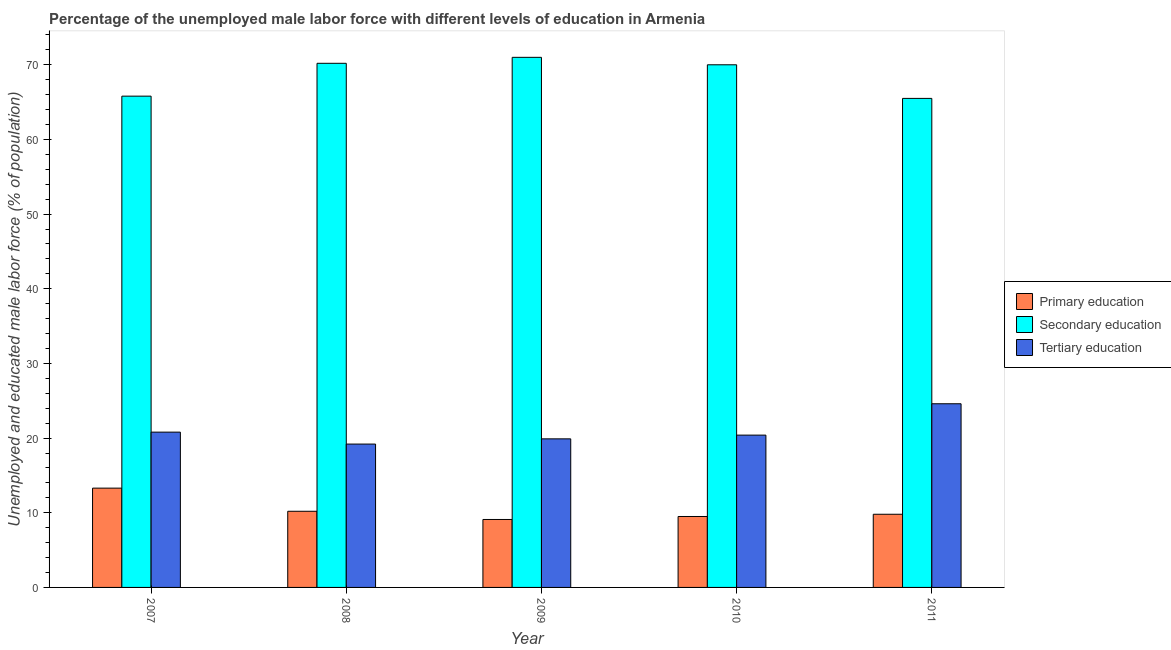Are the number of bars on each tick of the X-axis equal?
Give a very brief answer. Yes. How many bars are there on the 4th tick from the left?
Offer a terse response. 3. What is the label of the 1st group of bars from the left?
Offer a terse response. 2007. What is the percentage of male labor force who received primary education in 2008?
Your answer should be very brief. 10.2. Across all years, what is the maximum percentage of male labor force who received tertiary education?
Your answer should be compact. 24.6. Across all years, what is the minimum percentage of male labor force who received primary education?
Ensure brevity in your answer.  9.1. In which year was the percentage of male labor force who received tertiary education maximum?
Make the answer very short. 2011. What is the total percentage of male labor force who received tertiary education in the graph?
Give a very brief answer. 104.9. What is the difference between the percentage of male labor force who received tertiary education in 2007 and the percentage of male labor force who received secondary education in 2008?
Ensure brevity in your answer.  1.6. What is the average percentage of male labor force who received primary education per year?
Make the answer very short. 10.38. What is the ratio of the percentage of male labor force who received tertiary education in 2009 to that in 2010?
Offer a very short reply. 0.98. Is the difference between the percentage of male labor force who received tertiary education in 2010 and 2011 greater than the difference between the percentage of male labor force who received primary education in 2010 and 2011?
Offer a terse response. No. What is the difference between the highest and the second highest percentage of male labor force who received secondary education?
Ensure brevity in your answer.  0.8. What is the difference between the highest and the lowest percentage of male labor force who received primary education?
Your answer should be compact. 4.2. In how many years, is the percentage of male labor force who received primary education greater than the average percentage of male labor force who received primary education taken over all years?
Provide a succinct answer. 1. Is the sum of the percentage of male labor force who received secondary education in 2010 and 2011 greater than the maximum percentage of male labor force who received tertiary education across all years?
Provide a succinct answer. Yes. What does the 2nd bar from the left in 2011 represents?
Provide a succinct answer. Secondary education. How many bars are there?
Ensure brevity in your answer.  15. Are all the bars in the graph horizontal?
Your response must be concise. No. How many years are there in the graph?
Give a very brief answer. 5. What is the difference between two consecutive major ticks on the Y-axis?
Ensure brevity in your answer.  10. How many legend labels are there?
Ensure brevity in your answer.  3. What is the title of the graph?
Offer a very short reply. Percentage of the unemployed male labor force with different levels of education in Armenia. What is the label or title of the Y-axis?
Provide a succinct answer. Unemployed and educated male labor force (% of population). What is the Unemployed and educated male labor force (% of population) in Primary education in 2007?
Your answer should be compact. 13.3. What is the Unemployed and educated male labor force (% of population) in Secondary education in 2007?
Your answer should be compact. 65.8. What is the Unemployed and educated male labor force (% of population) of Tertiary education in 2007?
Your answer should be compact. 20.8. What is the Unemployed and educated male labor force (% of population) in Primary education in 2008?
Ensure brevity in your answer.  10.2. What is the Unemployed and educated male labor force (% of population) in Secondary education in 2008?
Give a very brief answer. 70.2. What is the Unemployed and educated male labor force (% of population) in Tertiary education in 2008?
Your answer should be very brief. 19.2. What is the Unemployed and educated male labor force (% of population) of Primary education in 2009?
Give a very brief answer. 9.1. What is the Unemployed and educated male labor force (% of population) of Tertiary education in 2009?
Offer a terse response. 19.9. What is the Unemployed and educated male labor force (% of population) of Primary education in 2010?
Offer a terse response. 9.5. What is the Unemployed and educated male labor force (% of population) of Secondary education in 2010?
Give a very brief answer. 70. What is the Unemployed and educated male labor force (% of population) of Tertiary education in 2010?
Offer a very short reply. 20.4. What is the Unemployed and educated male labor force (% of population) of Primary education in 2011?
Keep it short and to the point. 9.8. What is the Unemployed and educated male labor force (% of population) of Secondary education in 2011?
Offer a very short reply. 65.5. What is the Unemployed and educated male labor force (% of population) of Tertiary education in 2011?
Provide a short and direct response. 24.6. Across all years, what is the maximum Unemployed and educated male labor force (% of population) of Primary education?
Your answer should be very brief. 13.3. Across all years, what is the maximum Unemployed and educated male labor force (% of population) in Tertiary education?
Provide a succinct answer. 24.6. Across all years, what is the minimum Unemployed and educated male labor force (% of population) in Primary education?
Ensure brevity in your answer.  9.1. Across all years, what is the minimum Unemployed and educated male labor force (% of population) in Secondary education?
Keep it short and to the point. 65.5. Across all years, what is the minimum Unemployed and educated male labor force (% of population) of Tertiary education?
Your answer should be compact. 19.2. What is the total Unemployed and educated male labor force (% of population) in Primary education in the graph?
Provide a short and direct response. 51.9. What is the total Unemployed and educated male labor force (% of population) in Secondary education in the graph?
Offer a very short reply. 342.5. What is the total Unemployed and educated male labor force (% of population) in Tertiary education in the graph?
Provide a succinct answer. 104.9. What is the difference between the Unemployed and educated male labor force (% of population) of Primary education in 2007 and that in 2008?
Provide a short and direct response. 3.1. What is the difference between the Unemployed and educated male labor force (% of population) of Secondary education in 2007 and that in 2008?
Keep it short and to the point. -4.4. What is the difference between the Unemployed and educated male labor force (% of population) of Secondary education in 2007 and that in 2009?
Ensure brevity in your answer.  -5.2. What is the difference between the Unemployed and educated male labor force (% of population) in Tertiary education in 2007 and that in 2009?
Keep it short and to the point. 0.9. What is the difference between the Unemployed and educated male labor force (% of population) of Primary education in 2007 and that in 2010?
Offer a terse response. 3.8. What is the difference between the Unemployed and educated male labor force (% of population) in Secondary education in 2007 and that in 2010?
Keep it short and to the point. -4.2. What is the difference between the Unemployed and educated male labor force (% of population) of Primary education in 2007 and that in 2011?
Offer a terse response. 3.5. What is the difference between the Unemployed and educated male labor force (% of population) in Secondary education in 2007 and that in 2011?
Keep it short and to the point. 0.3. What is the difference between the Unemployed and educated male labor force (% of population) of Tertiary education in 2007 and that in 2011?
Ensure brevity in your answer.  -3.8. What is the difference between the Unemployed and educated male labor force (% of population) in Primary education in 2008 and that in 2009?
Provide a short and direct response. 1.1. What is the difference between the Unemployed and educated male labor force (% of population) of Secondary education in 2008 and that in 2009?
Make the answer very short. -0.8. What is the difference between the Unemployed and educated male labor force (% of population) in Tertiary education in 2008 and that in 2009?
Keep it short and to the point. -0.7. What is the difference between the Unemployed and educated male labor force (% of population) of Tertiary education in 2008 and that in 2010?
Make the answer very short. -1.2. What is the difference between the Unemployed and educated male labor force (% of population) in Primary education in 2008 and that in 2011?
Your answer should be compact. 0.4. What is the difference between the Unemployed and educated male labor force (% of population) in Primary education in 2009 and that in 2010?
Provide a succinct answer. -0.4. What is the difference between the Unemployed and educated male labor force (% of population) of Secondary education in 2009 and that in 2010?
Provide a succinct answer. 1. What is the difference between the Unemployed and educated male labor force (% of population) in Tertiary education in 2009 and that in 2010?
Make the answer very short. -0.5. What is the difference between the Unemployed and educated male labor force (% of population) of Tertiary education in 2009 and that in 2011?
Your response must be concise. -4.7. What is the difference between the Unemployed and educated male labor force (% of population) of Primary education in 2010 and that in 2011?
Provide a succinct answer. -0.3. What is the difference between the Unemployed and educated male labor force (% of population) in Tertiary education in 2010 and that in 2011?
Ensure brevity in your answer.  -4.2. What is the difference between the Unemployed and educated male labor force (% of population) of Primary education in 2007 and the Unemployed and educated male labor force (% of population) of Secondary education in 2008?
Your answer should be very brief. -56.9. What is the difference between the Unemployed and educated male labor force (% of population) of Primary education in 2007 and the Unemployed and educated male labor force (% of population) of Tertiary education in 2008?
Your response must be concise. -5.9. What is the difference between the Unemployed and educated male labor force (% of population) of Secondary education in 2007 and the Unemployed and educated male labor force (% of population) of Tertiary education in 2008?
Give a very brief answer. 46.6. What is the difference between the Unemployed and educated male labor force (% of population) in Primary education in 2007 and the Unemployed and educated male labor force (% of population) in Secondary education in 2009?
Offer a very short reply. -57.7. What is the difference between the Unemployed and educated male labor force (% of population) of Secondary education in 2007 and the Unemployed and educated male labor force (% of population) of Tertiary education in 2009?
Ensure brevity in your answer.  45.9. What is the difference between the Unemployed and educated male labor force (% of population) of Primary education in 2007 and the Unemployed and educated male labor force (% of population) of Secondary education in 2010?
Provide a short and direct response. -56.7. What is the difference between the Unemployed and educated male labor force (% of population) in Secondary education in 2007 and the Unemployed and educated male labor force (% of population) in Tertiary education in 2010?
Provide a succinct answer. 45.4. What is the difference between the Unemployed and educated male labor force (% of population) in Primary education in 2007 and the Unemployed and educated male labor force (% of population) in Secondary education in 2011?
Offer a terse response. -52.2. What is the difference between the Unemployed and educated male labor force (% of population) in Secondary education in 2007 and the Unemployed and educated male labor force (% of population) in Tertiary education in 2011?
Provide a short and direct response. 41.2. What is the difference between the Unemployed and educated male labor force (% of population) in Primary education in 2008 and the Unemployed and educated male labor force (% of population) in Secondary education in 2009?
Your response must be concise. -60.8. What is the difference between the Unemployed and educated male labor force (% of population) of Secondary education in 2008 and the Unemployed and educated male labor force (% of population) of Tertiary education in 2009?
Your answer should be very brief. 50.3. What is the difference between the Unemployed and educated male labor force (% of population) in Primary education in 2008 and the Unemployed and educated male labor force (% of population) in Secondary education in 2010?
Your response must be concise. -59.8. What is the difference between the Unemployed and educated male labor force (% of population) in Secondary education in 2008 and the Unemployed and educated male labor force (% of population) in Tertiary education in 2010?
Keep it short and to the point. 49.8. What is the difference between the Unemployed and educated male labor force (% of population) of Primary education in 2008 and the Unemployed and educated male labor force (% of population) of Secondary education in 2011?
Your answer should be very brief. -55.3. What is the difference between the Unemployed and educated male labor force (% of population) in Primary education in 2008 and the Unemployed and educated male labor force (% of population) in Tertiary education in 2011?
Your response must be concise. -14.4. What is the difference between the Unemployed and educated male labor force (% of population) of Secondary education in 2008 and the Unemployed and educated male labor force (% of population) of Tertiary education in 2011?
Offer a terse response. 45.6. What is the difference between the Unemployed and educated male labor force (% of population) of Primary education in 2009 and the Unemployed and educated male labor force (% of population) of Secondary education in 2010?
Provide a short and direct response. -60.9. What is the difference between the Unemployed and educated male labor force (% of population) in Secondary education in 2009 and the Unemployed and educated male labor force (% of population) in Tertiary education in 2010?
Offer a very short reply. 50.6. What is the difference between the Unemployed and educated male labor force (% of population) of Primary education in 2009 and the Unemployed and educated male labor force (% of population) of Secondary education in 2011?
Provide a short and direct response. -56.4. What is the difference between the Unemployed and educated male labor force (% of population) in Primary education in 2009 and the Unemployed and educated male labor force (% of population) in Tertiary education in 2011?
Give a very brief answer. -15.5. What is the difference between the Unemployed and educated male labor force (% of population) of Secondary education in 2009 and the Unemployed and educated male labor force (% of population) of Tertiary education in 2011?
Your answer should be very brief. 46.4. What is the difference between the Unemployed and educated male labor force (% of population) in Primary education in 2010 and the Unemployed and educated male labor force (% of population) in Secondary education in 2011?
Make the answer very short. -56. What is the difference between the Unemployed and educated male labor force (% of population) of Primary education in 2010 and the Unemployed and educated male labor force (% of population) of Tertiary education in 2011?
Make the answer very short. -15.1. What is the difference between the Unemployed and educated male labor force (% of population) in Secondary education in 2010 and the Unemployed and educated male labor force (% of population) in Tertiary education in 2011?
Your answer should be compact. 45.4. What is the average Unemployed and educated male labor force (% of population) in Primary education per year?
Offer a very short reply. 10.38. What is the average Unemployed and educated male labor force (% of population) in Secondary education per year?
Give a very brief answer. 68.5. What is the average Unemployed and educated male labor force (% of population) in Tertiary education per year?
Make the answer very short. 20.98. In the year 2007, what is the difference between the Unemployed and educated male labor force (% of population) of Primary education and Unemployed and educated male labor force (% of population) of Secondary education?
Ensure brevity in your answer.  -52.5. In the year 2007, what is the difference between the Unemployed and educated male labor force (% of population) in Secondary education and Unemployed and educated male labor force (% of population) in Tertiary education?
Make the answer very short. 45. In the year 2008, what is the difference between the Unemployed and educated male labor force (% of population) in Primary education and Unemployed and educated male labor force (% of population) in Secondary education?
Your answer should be very brief. -60. In the year 2008, what is the difference between the Unemployed and educated male labor force (% of population) of Secondary education and Unemployed and educated male labor force (% of population) of Tertiary education?
Offer a very short reply. 51. In the year 2009, what is the difference between the Unemployed and educated male labor force (% of population) in Primary education and Unemployed and educated male labor force (% of population) in Secondary education?
Ensure brevity in your answer.  -61.9. In the year 2009, what is the difference between the Unemployed and educated male labor force (% of population) in Secondary education and Unemployed and educated male labor force (% of population) in Tertiary education?
Your response must be concise. 51.1. In the year 2010, what is the difference between the Unemployed and educated male labor force (% of population) in Primary education and Unemployed and educated male labor force (% of population) in Secondary education?
Offer a terse response. -60.5. In the year 2010, what is the difference between the Unemployed and educated male labor force (% of population) of Secondary education and Unemployed and educated male labor force (% of population) of Tertiary education?
Make the answer very short. 49.6. In the year 2011, what is the difference between the Unemployed and educated male labor force (% of population) in Primary education and Unemployed and educated male labor force (% of population) in Secondary education?
Ensure brevity in your answer.  -55.7. In the year 2011, what is the difference between the Unemployed and educated male labor force (% of population) in Primary education and Unemployed and educated male labor force (% of population) in Tertiary education?
Ensure brevity in your answer.  -14.8. In the year 2011, what is the difference between the Unemployed and educated male labor force (% of population) in Secondary education and Unemployed and educated male labor force (% of population) in Tertiary education?
Your answer should be compact. 40.9. What is the ratio of the Unemployed and educated male labor force (% of population) in Primary education in 2007 to that in 2008?
Your answer should be very brief. 1.3. What is the ratio of the Unemployed and educated male labor force (% of population) of Secondary education in 2007 to that in 2008?
Offer a terse response. 0.94. What is the ratio of the Unemployed and educated male labor force (% of population) in Tertiary education in 2007 to that in 2008?
Make the answer very short. 1.08. What is the ratio of the Unemployed and educated male labor force (% of population) in Primary education in 2007 to that in 2009?
Offer a very short reply. 1.46. What is the ratio of the Unemployed and educated male labor force (% of population) of Secondary education in 2007 to that in 2009?
Make the answer very short. 0.93. What is the ratio of the Unemployed and educated male labor force (% of population) of Tertiary education in 2007 to that in 2009?
Your answer should be very brief. 1.05. What is the ratio of the Unemployed and educated male labor force (% of population) of Primary education in 2007 to that in 2010?
Keep it short and to the point. 1.4. What is the ratio of the Unemployed and educated male labor force (% of population) of Tertiary education in 2007 to that in 2010?
Your answer should be very brief. 1.02. What is the ratio of the Unemployed and educated male labor force (% of population) of Primary education in 2007 to that in 2011?
Give a very brief answer. 1.36. What is the ratio of the Unemployed and educated male labor force (% of population) in Secondary education in 2007 to that in 2011?
Your answer should be very brief. 1. What is the ratio of the Unemployed and educated male labor force (% of population) of Tertiary education in 2007 to that in 2011?
Your response must be concise. 0.85. What is the ratio of the Unemployed and educated male labor force (% of population) in Primary education in 2008 to that in 2009?
Provide a short and direct response. 1.12. What is the ratio of the Unemployed and educated male labor force (% of population) of Secondary education in 2008 to that in 2009?
Provide a succinct answer. 0.99. What is the ratio of the Unemployed and educated male labor force (% of population) of Tertiary education in 2008 to that in 2009?
Offer a very short reply. 0.96. What is the ratio of the Unemployed and educated male labor force (% of population) in Primary education in 2008 to that in 2010?
Provide a succinct answer. 1.07. What is the ratio of the Unemployed and educated male labor force (% of population) of Primary education in 2008 to that in 2011?
Provide a succinct answer. 1.04. What is the ratio of the Unemployed and educated male labor force (% of population) in Secondary education in 2008 to that in 2011?
Ensure brevity in your answer.  1.07. What is the ratio of the Unemployed and educated male labor force (% of population) in Tertiary education in 2008 to that in 2011?
Give a very brief answer. 0.78. What is the ratio of the Unemployed and educated male labor force (% of population) in Primary education in 2009 to that in 2010?
Keep it short and to the point. 0.96. What is the ratio of the Unemployed and educated male labor force (% of population) of Secondary education in 2009 to that in 2010?
Offer a very short reply. 1.01. What is the ratio of the Unemployed and educated male labor force (% of population) in Tertiary education in 2009 to that in 2010?
Your answer should be compact. 0.98. What is the ratio of the Unemployed and educated male labor force (% of population) of Primary education in 2009 to that in 2011?
Your answer should be very brief. 0.93. What is the ratio of the Unemployed and educated male labor force (% of population) in Secondary education in 2009 to that in 2011?
Offer a terse response. 1.08. What is the ratio of the Unemployed and educated male labor force (% of population) of Tertiary education in 2009 to that in 2011?
Give a very brief answer. 0.81. What is the ratio of the Unemployed and educated male labor force (% of population) in Primary education in 2010 to that in 2011?
Your response must be concise. 0.97. What is the ratio of the Unemployed and educated male labor force (% of population) in Secondary education in 2010 to that in 2011?
Ensure brevity in your answer.  1.07. What is the ratio of the Unemployed and educated male labor force (% of population) in Tertiary education in 2010 to that in 2011?
Make the answer very short. 0.83. What is the difference between the highest and the second highest Unemployed and educated male labor force (% of population) of Primary education?
Keep it short and to the point. 3.1. What is the difference between the highest and the second highest Unemployed and educated male labor force (% of population) of Secondary education?
Your answer should be compact. 0.8. What is the difference between the highest and the lowest Unemployed and educated male labor force (% of population) in Secondary education?
Your answer should be compact. 5.5. 